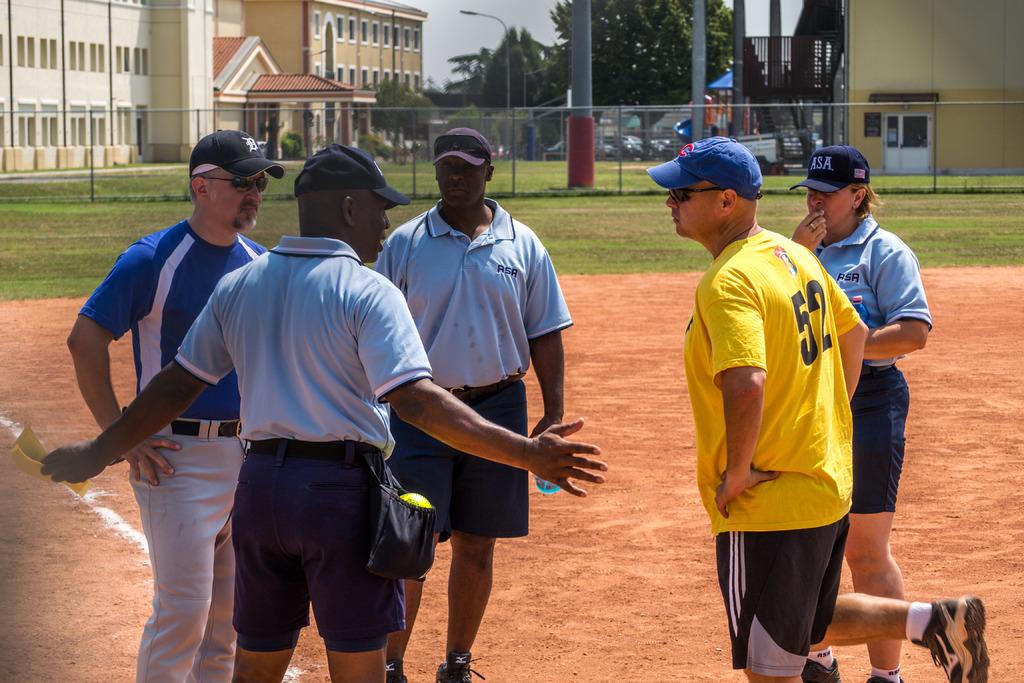What is on the lady's cap?
Make the answer very short. Asa. 